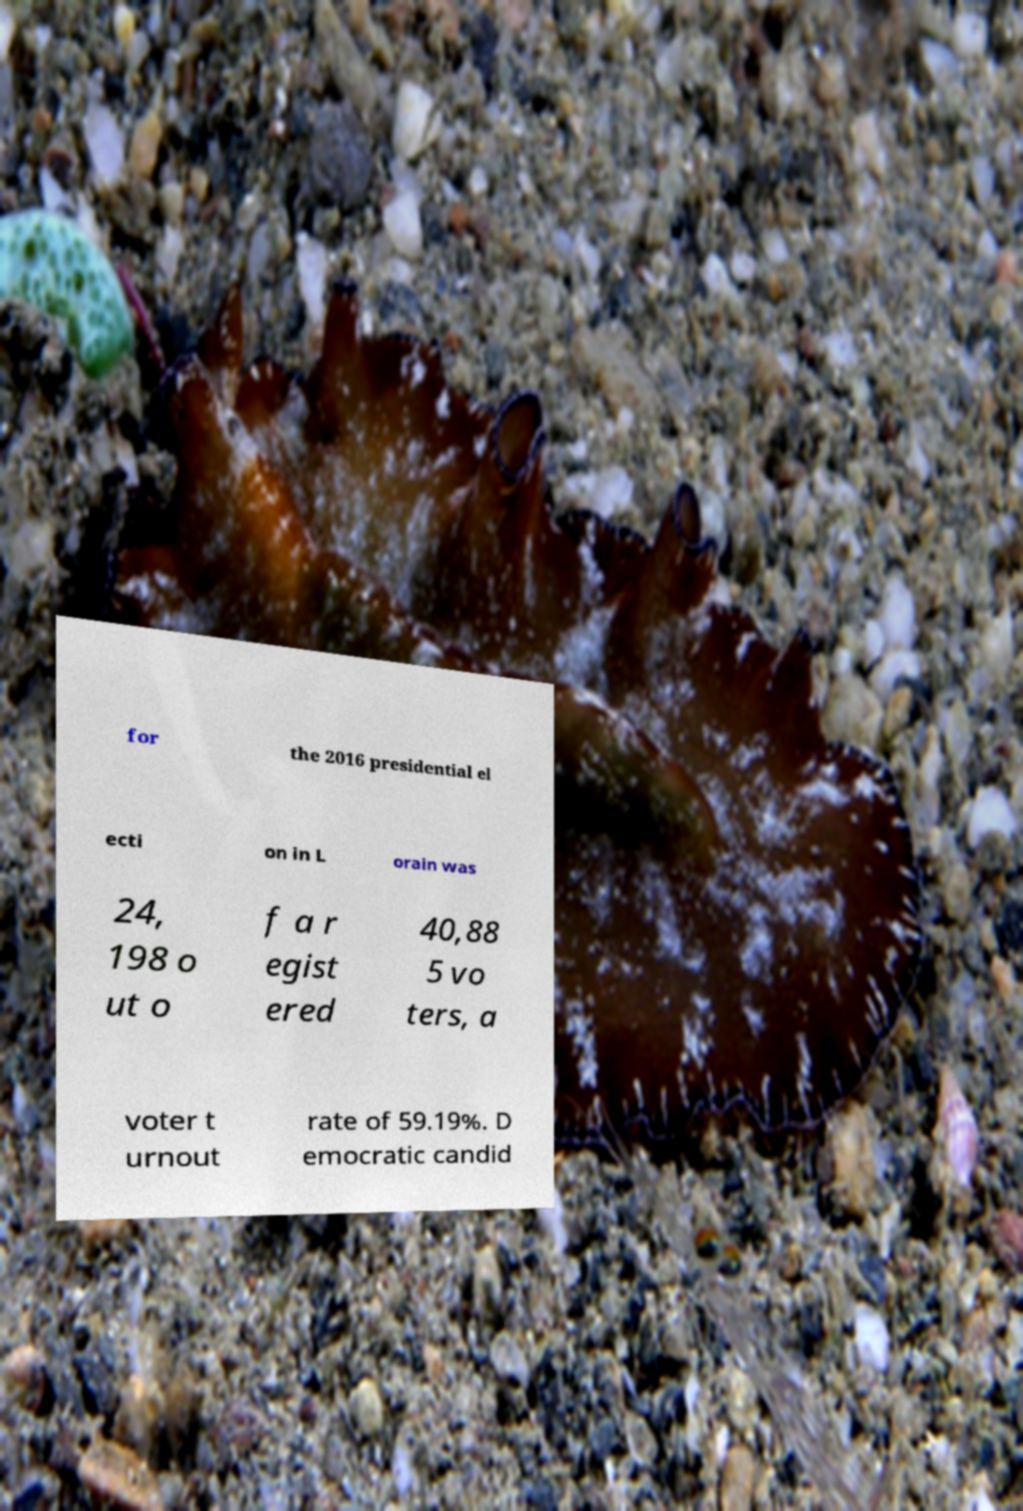What messages or text are displayed in this image? I need them in a readable, typed format. for the 2016 presidential el ecti on in L orain was 24, 198 o ut o f a r egist ered 40,88 5 vo ters, a voter t urnout rate of 59.19%. D emocratic candid 